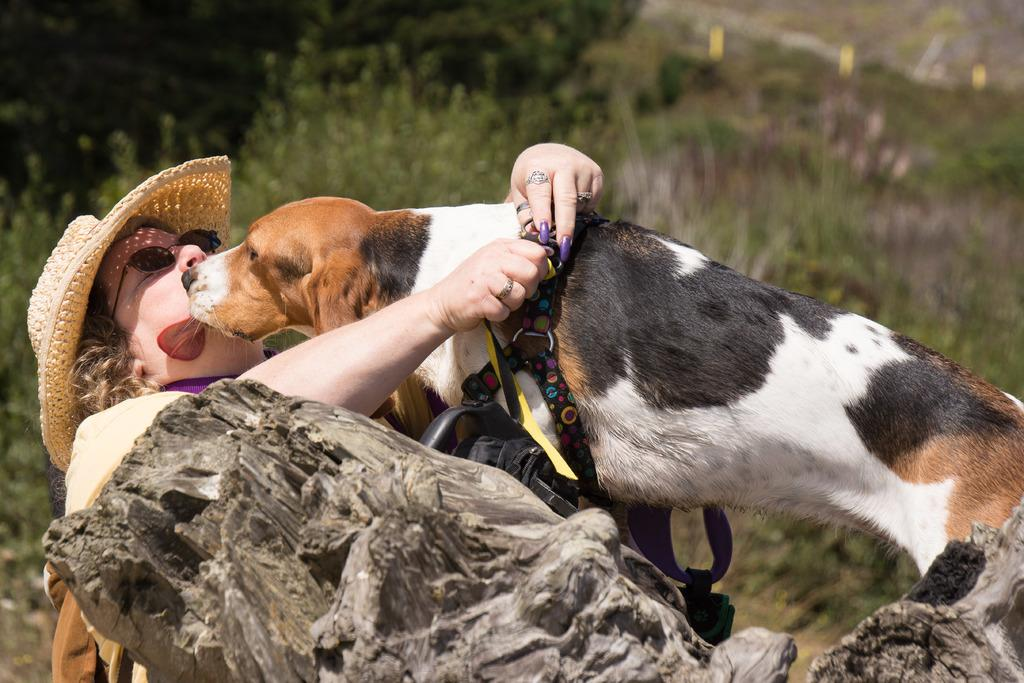What animal is on the tree in the image? There is a dog on the tree in the image. Where is the woman located in the image? The woman is on the left side of the image. What accessories is the woman wearing? The woman is wearing a hat and spectacles. What can be seen in the background of the image? There are plants and trees in the background of the image. How many pizzas are being served at the church in the image? There is no mention of pizzas or a church in the image; it features a dog on a tree and a woman on the left side. 